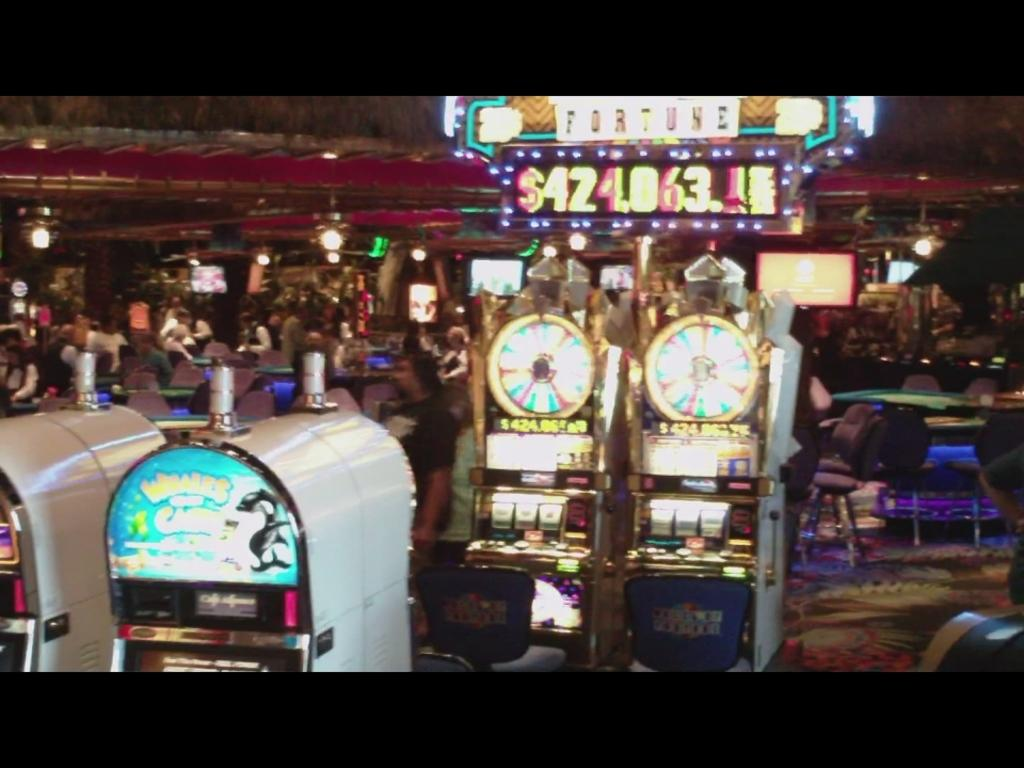What are the people in the image doing? There are persons standing and sitting in the image. What objects can be seen in the image besides the people? There are gaming machines in the image. What type of illumination is present in the image? There are lights in the image. What type of dirt can be seen on the floor in the image? There is no dirt visible on the floor in the image. Can you see a hen in the image? There is no hen present in the image. 